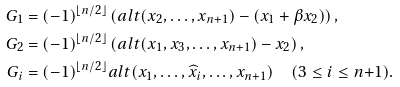Convert formula to latex. <formula><loc_0><loc_0><loc_500><loc_500>G _ { 1 } & = ( - 1 ) ^ { \lfloor n / 2 \rfloor } \left ( a l t ( x _ { 2 } , \dots , x _ { n + 1 } ) - ( x _ { 1 } + \beta x _ { 2 } ) \right ) , \\ G _ { 2 } & = ( - 1 ) ^ { \lfloor n / 2 \rfloor } \left ( a l t ( x _ { 1 } , x _ { 3 } , \dots , x _ { n + 1 } ) - x _ { 2 } \right ) , \\ G _ { i } & = ( - 1 ) ^ { \lfloor n / 2 \rfloor } a l t ( x _ { 1 } , \dots , \widehat { x } _ { i } , \dots , x _ { n + 1 } ) \quad ( 3 \leq i \leq n { + } 1 ) .</formula> 